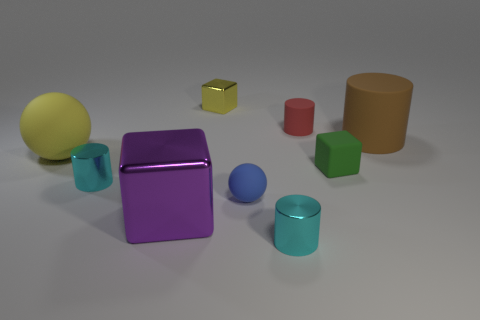Subtract all tiny blocks. How many blocks are left? 1 Add 1 tiny yellow things. How many objects exist? 10 Subtract 3 cylinders. How many cylinders are left? 1 Subtract all yellow balls. How many balls are left? 1 Subtract all cubes. How many objects are left? 6 Subtract 0 red spheres. How many objects are left? 9 Subtract all gray blocks. Subtract all red balls. How many blocks are left? 3 Subtract all purple blocks. How many cyan cylinders are left? 2 Subtract all tiny yellow metal things. Subtract all tiny green matte things. How many objects are left? 7 Add 5 small cyan metal cylinders. How many small cyan metal cylinders are left? 7 